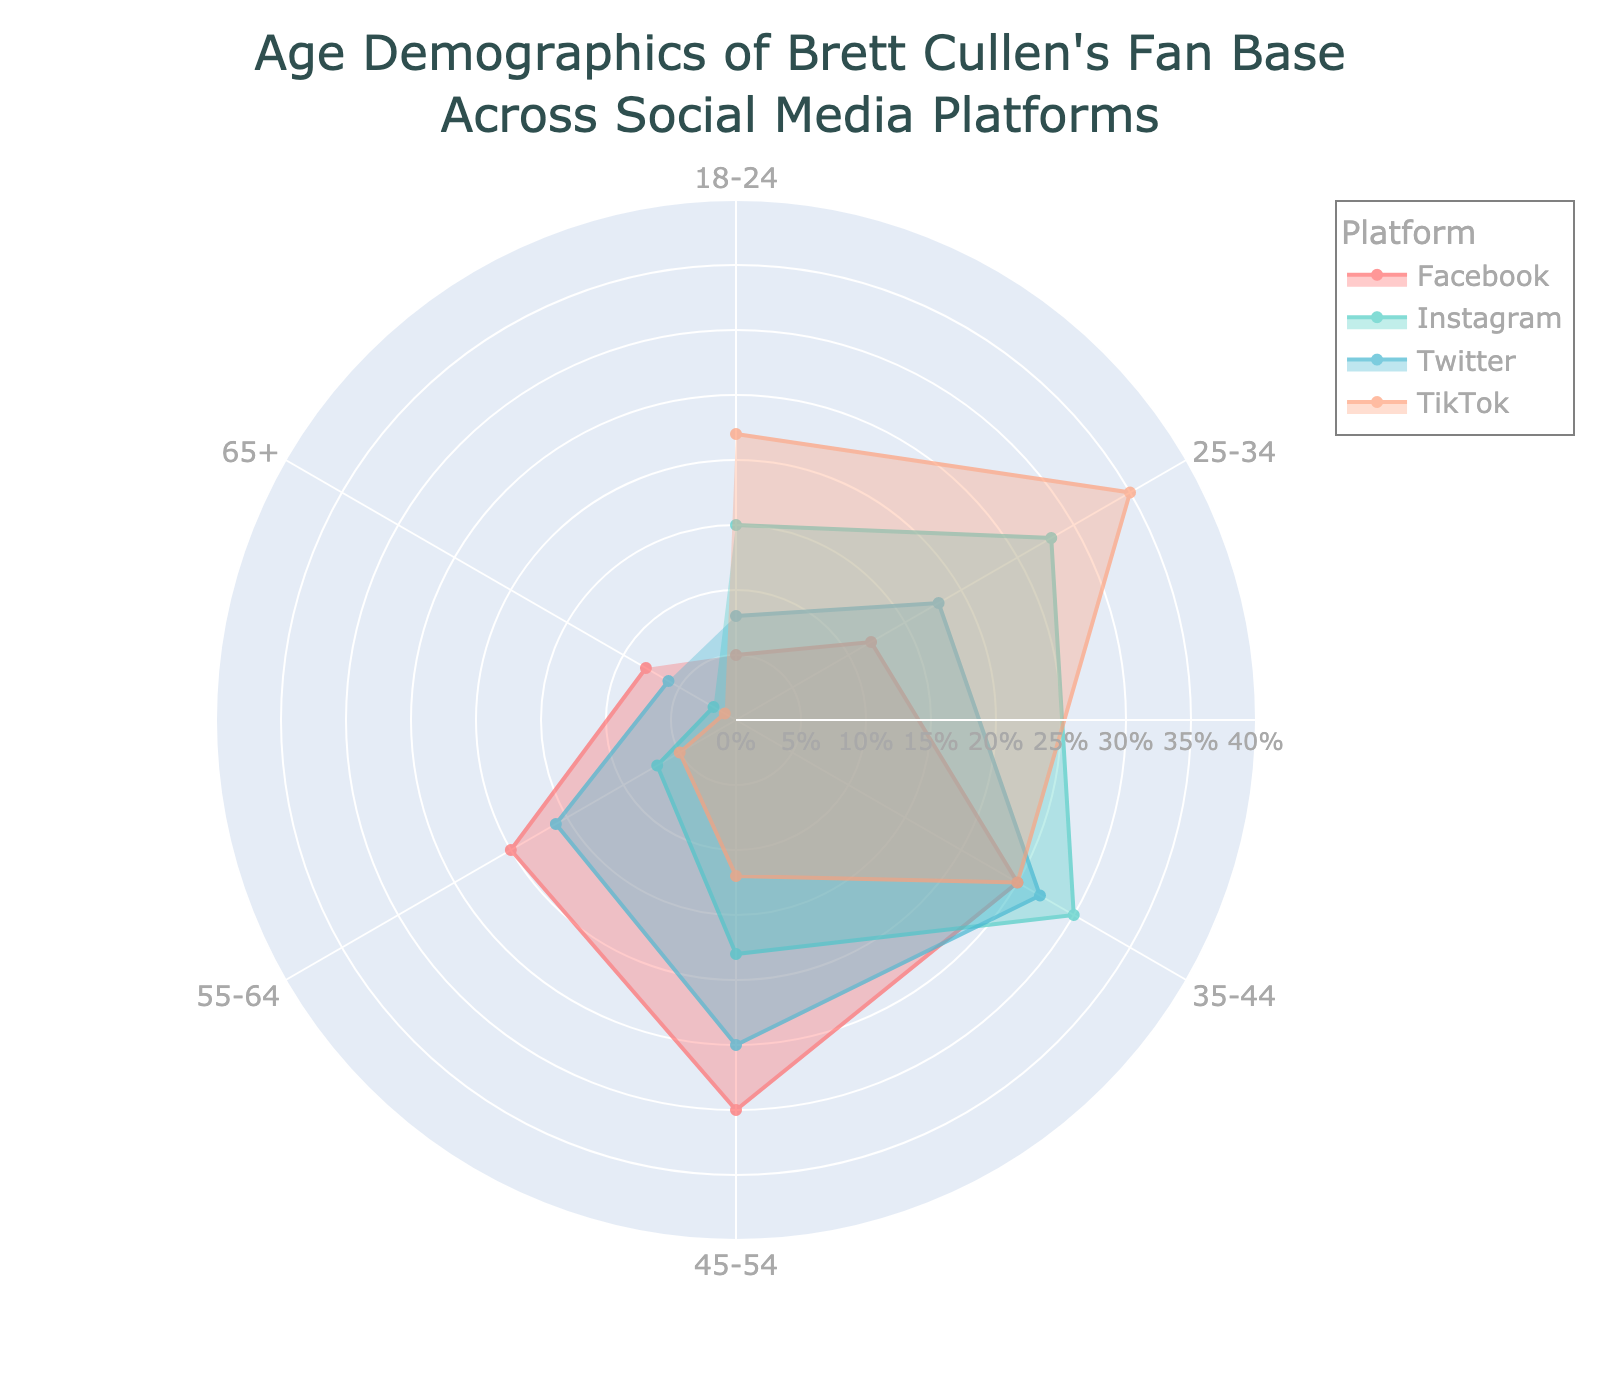Which platform has the highest percentage of fans aged 18-24? Identify the section of the chart for each platform at the 18-24 age range and compare the values. TikTok has the highest percentage.
Answer: TikTok Which age range has the highest percentage of Facebook fans? Find the age range on the chart with the highest radial distance for the Facebook segment. The 45-54 age range has the highest percentage for Facebook.
Answer: 45-54 What's the total percentage of Instagram fans in the 35-44 and 45-54 age ranges? Sum the percentages of Instagram fans in these two age ranges: 30% (35-44) + 18% (45-54).
Answer: 48% Is the percentage of Twitter fans in the 25-34 age range higher or lower than that of Instagram? Compare the 25-34 percentages for Twitter and Instagram. Twitter has 18%, while Instagram has 28%, so Twitter is lower.
Answer: Lower Which platform has the smallest proportion of fans in the 65+ age range? Identify the 65+ section for each platform and find the smallest percentage. TikTok has the smallest proportion at 1%.
Answer: TikTok What's the average percentage of fans aged 55-64 for all platforms? Sum the percentages for all platforms in the 55-64 age range and then divide by 4: (20% (Facebook) + 7% (Instagram) + 16% (Twitter) + 5% (TikTok)) / 4 = 48% / 4.
Answer: 12% Compare the percentage of fans aged 35-44 on Facebook and Twitter. Who has higher engagement? Check the 35-44 percentages for Facebook and Twitter. Facebook has 25%, and Twitter has 27%, so Twitter has higher engagement.
Answer: Twitter Which age range has the most balanced fan distribution across all platforms? Look at each age range and compare the variance in percentages across platforms. The 35-44 age range appears most balanced as it has significant representation across all platforms.
Answer: 35-44 